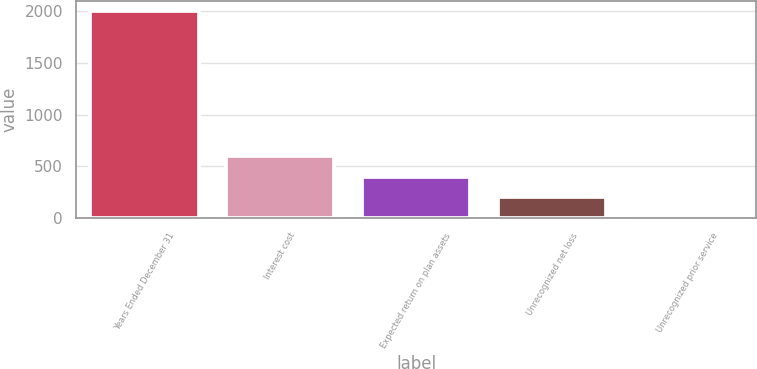Convert chart to OTSL. <chart><loc_0><loc_0><loc_500><loc_500><bar_chart><fcel>Years Ended December 31<fcel>Interest cost<fcel>Expected return on plan assets<fcel>Unrecognized net loss<fcel>Unrecognized prior service<nl><fcel>2002<fcel>601.3<fcel>401.2<fcel>201.1<fcel>1<nl></chart> 